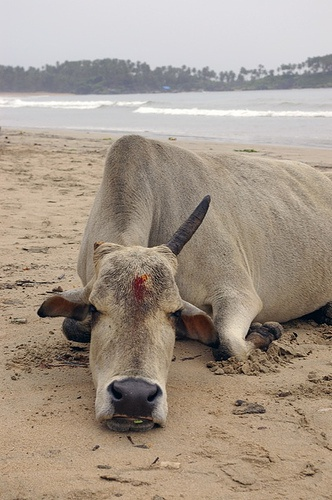Describe the objects in this image and their specific colors. I can see a cow in lightgray, darkgray, and gray tones in this image. 